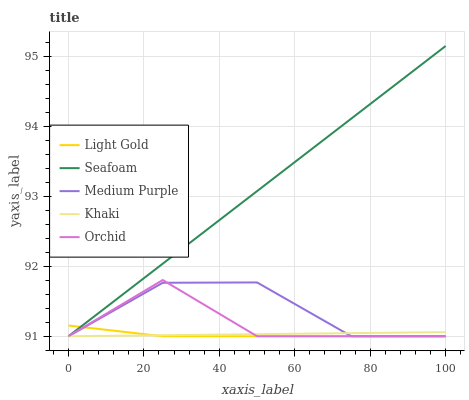Does Khaki have the minimum area under the curve?
Answer yes or no. No. Does Khaki have the maximum area under the curve?
Answer yes or no. No. Is Light Gold the smoothest?
Answer yes or no. No. Is Light Gold the roughest?
Answer yes or no. No. Does Light Gold have the highest value?
Answer yes or no. No. 